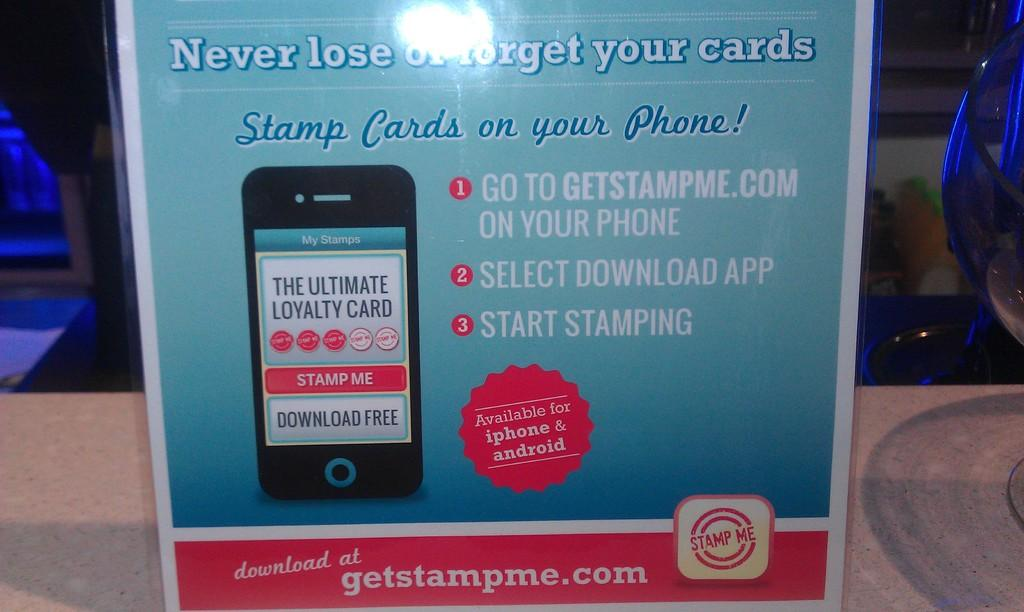Provide a one-sentence caption for the provided image. A flyer for an app for your phone called get stamp me. 